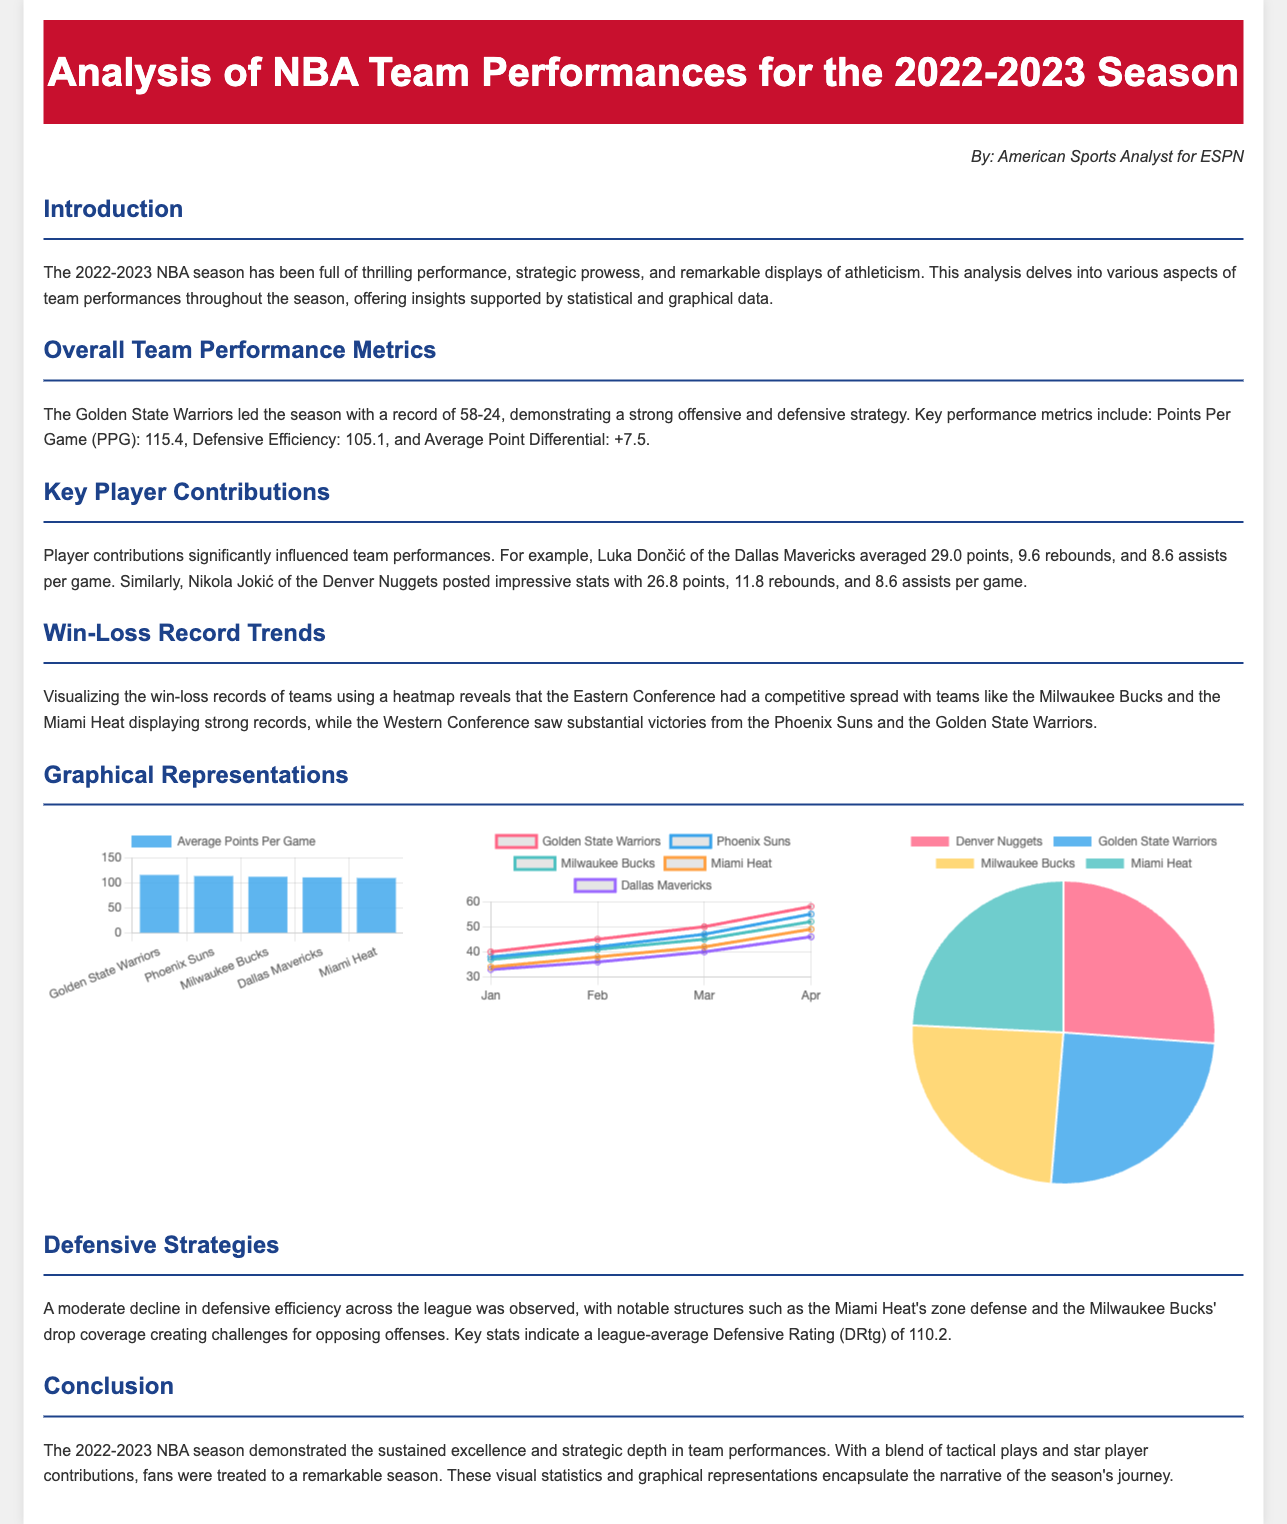What was the Golden State Warriors' record? The record for the Golden State Warriors in the 2022-2023 season was leading at 58-24.
Answer: 58-24 Who averaged the most points per game in the analysis? Luka Dončić of the Dallas Mavericks is noted for averaging 29.0 points per game.
Answer: Luka Dončić What was the league-average Defensive Rating? The league-average Defensive Rating is cited as 110.2 in the document.
Answer: 110.2 Which team showed a moderate decline in defensive efficiency? The document mentions the Miami Heat regarding their zone defense contributing to the decline in efficiency.
Answer: Miami Heat What is the average points per game for the Milwaukee Bucks? The average points per game for the Milwaukee Bucks can be retrieved from the bar chart as 111.8.
Answer: 111.8 How many rebounds did Nikola Jokić average? Nikola Jokić averaged 11.8 rebounds per game as stated in the key player contributions section.
Answer: 11.8 Which chart represents the distribution of total rebounds? The pie chart provides a visual representation of the distribution of total rebounds for the specified teams.
Answer: Pie chart What trend does the line chart illustrate? The line chart illustrates the win-loss record trends among the top five teams over specified months.
Answer: Win-loss record trends 